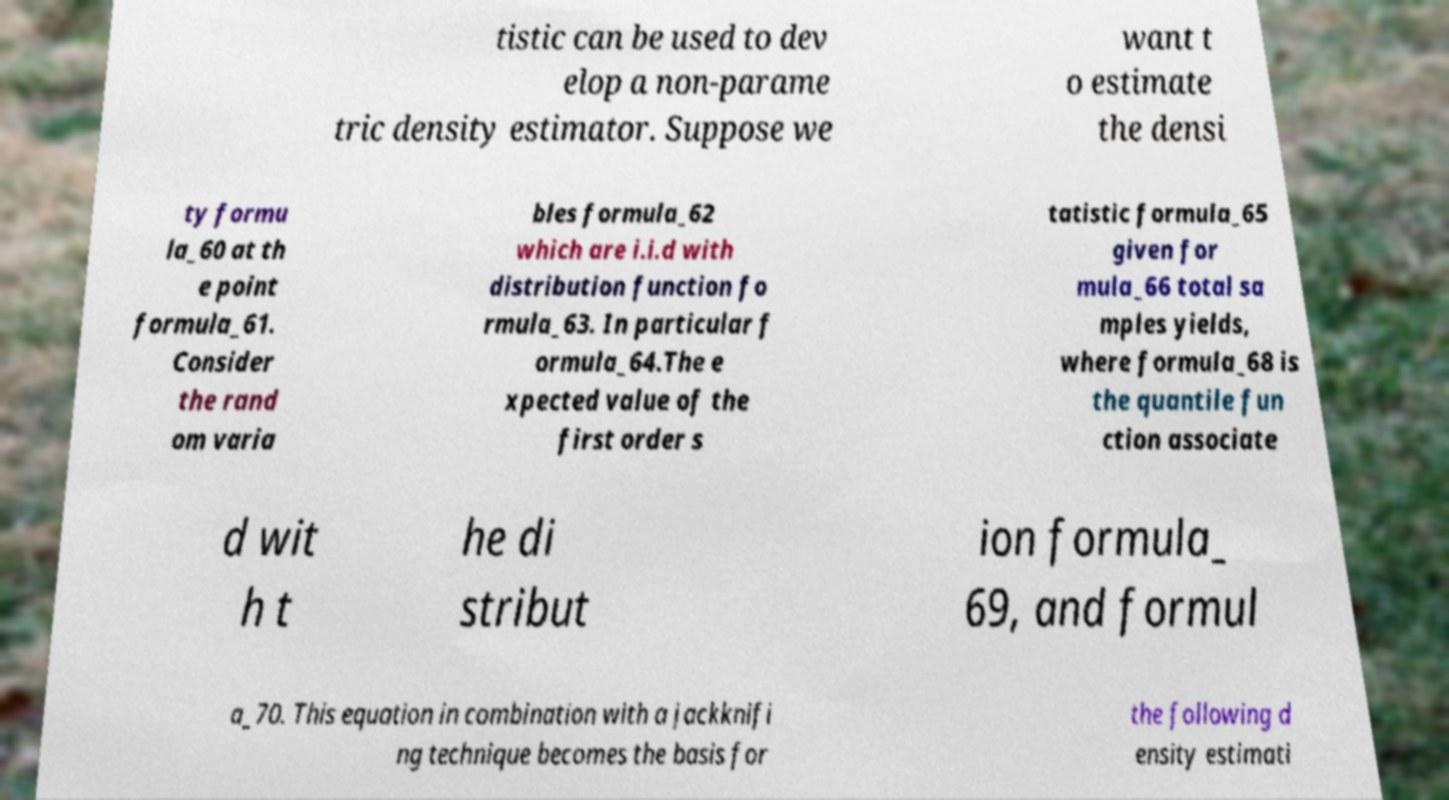Could you assist in decoding the text presented in this image and type it out clearly? tistic can be used to dev elop a non-parame tric density estimator. Suppose we want t o estimate the densi ty formu la_60 at th e point formula_61. Consider the rand om varia bles formula_62 which are i.i.d with distribution function fo rmula_63. In particular f ormula_64.The e xpected value of the first order s tatistic formula_65 given for mula_66 total sa mples yields, where formula_68 is the quantile fun ction associate d wit h t he di stribut ion formula_ 69, and formul a_70. This equation in combination with a jackknifi ng technique becomes the basis for the following d ensity estimati 